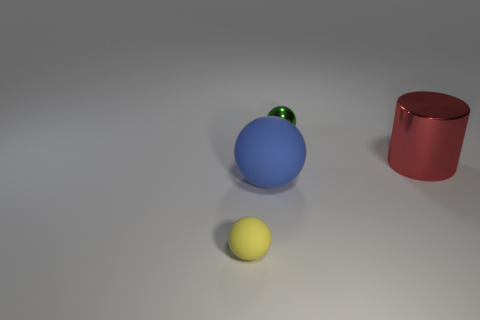Can you describe what the surface looks like in terms of texture and color? The surface on which the objects are placed appears to have a smooth texture with a neutral grey color. It emulates a soft, diffused reflection, suggesting it might have a matte finish similar to brushed metal or stone. 